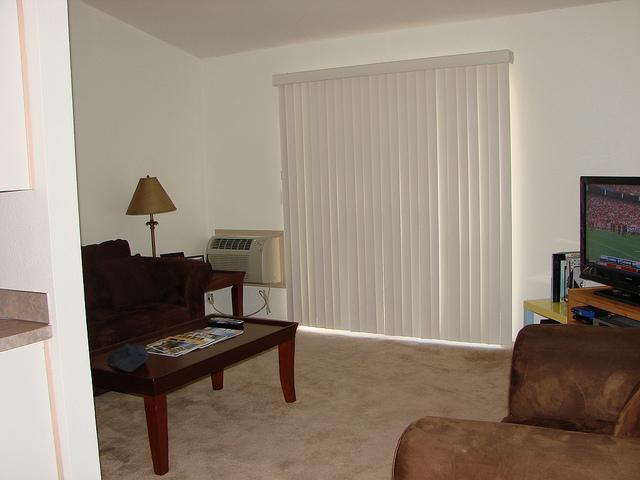How many couches are in the picture?
Give a very brief answer. 2. How many people are skiing?
Give a very brief answer. 0. 